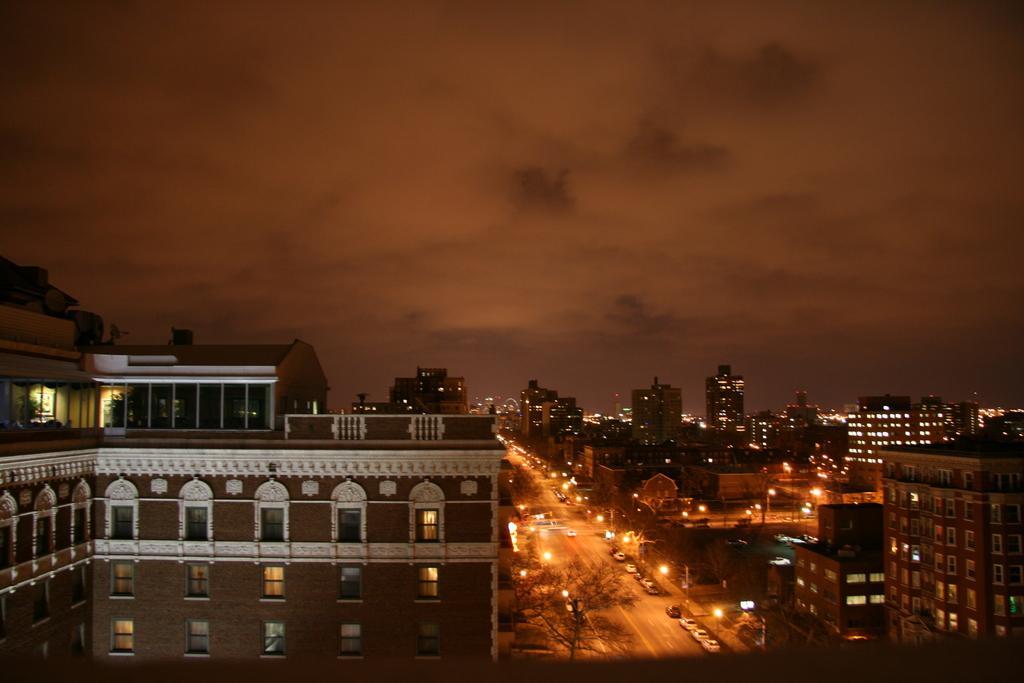Could you give a brief overview of what you see in this image? In this image we can see the buildings with lights and there are vehicles on the road. We can see the street lights, trees and sky in the background. 